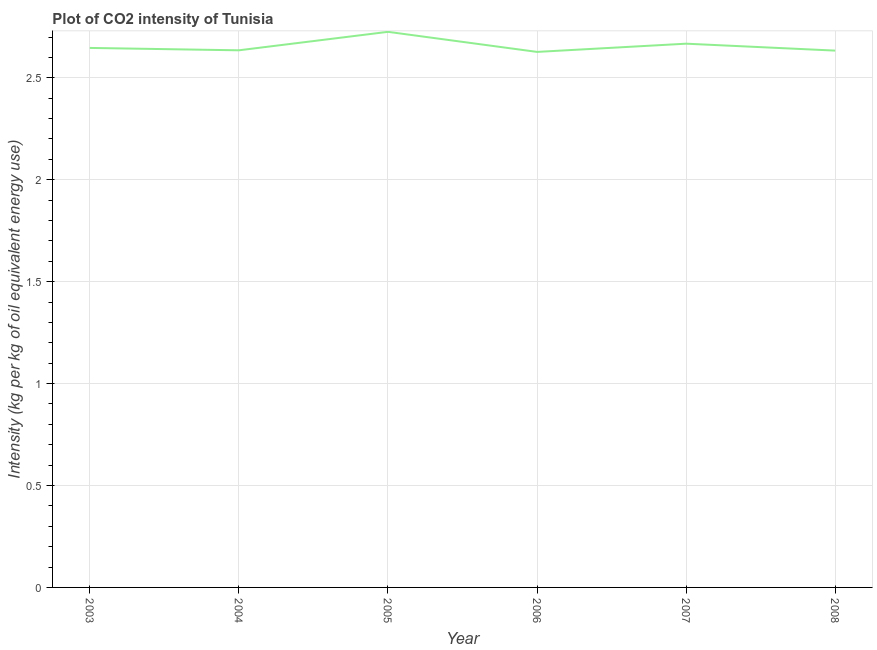What is the co2 intensity in 2007?
Give a very brief answer. 2.67. Across all years, what is the maximum co2 intensity?
Ensure brevity in your answer.  2.73. Across all years, what is the minimum co2 intensity?
Ensure brevity in your answer.  2.63. What is the sum of the co2 intensity?
Keep it short and to the point. 15.94. What is the difference between the co2 intensity in 2003 and 2005?
Offer a very short reply. -0.08. What is the average co2 intensity per year?
Keep it short and to the point. 2.66. What is the median co2 intensity?
Give a very brief answer. 2.64. What is the ratio of the co2 intensity in 2003 to that in 2006?
Provide a succinct answer. 1.01. What is the difference between the highest and the second highest co2 intensity?
Your answer should be very brief. 0.06. What is the difference between the highest and the lowest co2 intensity?
Your answer should be compact. 0.1. Does the co2 intensity monotonically increase over the years?
Provide a succinct answer. No. How many years are there in the graph?
Make the answer very short. 6. Does the graph contain grids?
Your response must be concise. Yes. What is the title of the graph?
Ensure brevity in your answer.  Plot of CO2 intensity of Tunisia. What is the label or title of the Y-axis?
Your answer should be very brief. Intensity (kg per kg of oil equivalent energy use). What is the Intensity (kg per kg of oil equivalent energy use) in 2003?
Provide a succinct answer. 2.65. What is the Intensity (kg per kg of oil equivalent energy use) in 2004?
Give a very brief answer. 2.63. What is the Intensity (kg per kg of oil equivalent energy use) in 2005?
Ensure brevity in your answer.  2.73. What is the Intensity (kg per kg of oil equivalent energy use) of 2006?
Your response must be concise. 2.63. What is the Intensity (kg per kg of oil equivalent energy use) in 2007?
Your response must be concise. 2.67. What is the Intensity (kg per kg of oil equivalent energy use) in 2008?
Ensure brevity in your answer.  2.63. What is the difference between the Intensity (kg per kg of oil equivalent energy use) in 2003 and 2004?
Keep it short and to the point. 0.01. What is the difference between the Intensity (kg per kg of oil equivalent energy use) in 2003 and 2005?
Give a very brief answer. -0.08. What is the difference between the Intensity (kg per kg of oil equivalent energy use) in 2003 and 2006?
Your response must be concise. 0.02. What is the difference between the Intensity (kg per kg of oil equivalent energy use) in 2003 and 2007?
Provide a succinct answer. -0.02. What is the difference between the Intensity (kg per kg of oil equivalent energy use) in 2003 and 2008?
Your answer should be compact. 0.01. What is the difference between the Intensity (kg per kg of oil equivalent energy use) in 2004 and 2005?
Make the answer very short. -0.09. What is the difference between the Intensity (kg per kg of oil equivalent energy use) in 2004 and 2006?
Keep it short and to the point. 0.01. What is the difference between the Intensity (kg per kg of oil equivalent energy use) in 2004 and 2007?
Your response must be concise. -0.03. What is the difference between the Intensity (kg per kg of oil equivalent energy use) in 2004 and 2008?
Provide a short and direct response. 0. What is the difference between the Intensity (kg per kg of oil equivalent energy use) in 2005 and 2006?
Give a very brief answer. 0.1. What is the difference between the Intensity (kg per kg of oil equivalent energy use) in 2005 and 2007?
Offer a terse response. 0.06. What is the difference between the Intensity (kg per kg of oil equivalent energy use) in 2005 and 2008?
Provide a succinct answer. 0.09. What is the difference between the Intensity (kg per kg of oil equivalent energy use) in 2006 and 2007?
Provide a succinct answer. -0.04. What is the difference between the Intensity (kg per kg of oil equivalent energy use) in 2006 and 2008?
Your response must be concise. -0.01. What is the difference between the Intensity (kg per kg of oil equivalent energy use) in 2007 and 2008?
Your answer should be very brief. 0.03. What is the ratio of the Intensity (kg per kg of oil equivalent energy use) in 2003 to that in 2006?
Offer a terse response. 1.01. What is the ratio of the Intensity (kg per kg of oil equivalent energy use) in 2003 to that in 2007?
Offer a very short reply. 0.99. What is the ratio of the Intensity (kg per kg of oil equivalent energy use) in 2003 to that in 2008?
Keep it short and to the point. 1. What is the ratio of the Intensity (kg per kg of oil equivalent energy use) in 2004 to that in 2005?
Your answer should be compact. 0.97. What is the ratio of the Intensity (kg per kg of oil equivalent energy use) in 2004 to that in 2006?
Keep it short and to the point. 1. What is the ratio of the Intensity (kg per kg of oil equivalent energy use) in 2004 to that in 2007?
Your response must be concise. 0.99. What is the ratio of the Intensity (kg per kg of oil equivalent energy use) in 2004 to that in 2008?
Keep it short and to the point. 1. What is the ratio of the Intensity (kg per kg of oil equivalent energy use) in 2005 to that in 2006?
Keep it short and to the point. 1.04. What is the ratio of the Intensity (kg per kg of oil equivalent energy use) in 2005 to that in 2007?
Provide a succinct answer. 1.02. What is the ratio of the Intensity (kg per kg of oil equivalent energy use) in 2005 to that in 2008?
Offer a very short reply. 1.03. What is the ratio of the Intensity (kg per kg of oil equivalent energy use) in 2006 to that in 2008?
Provide a succinct answer. 1. 